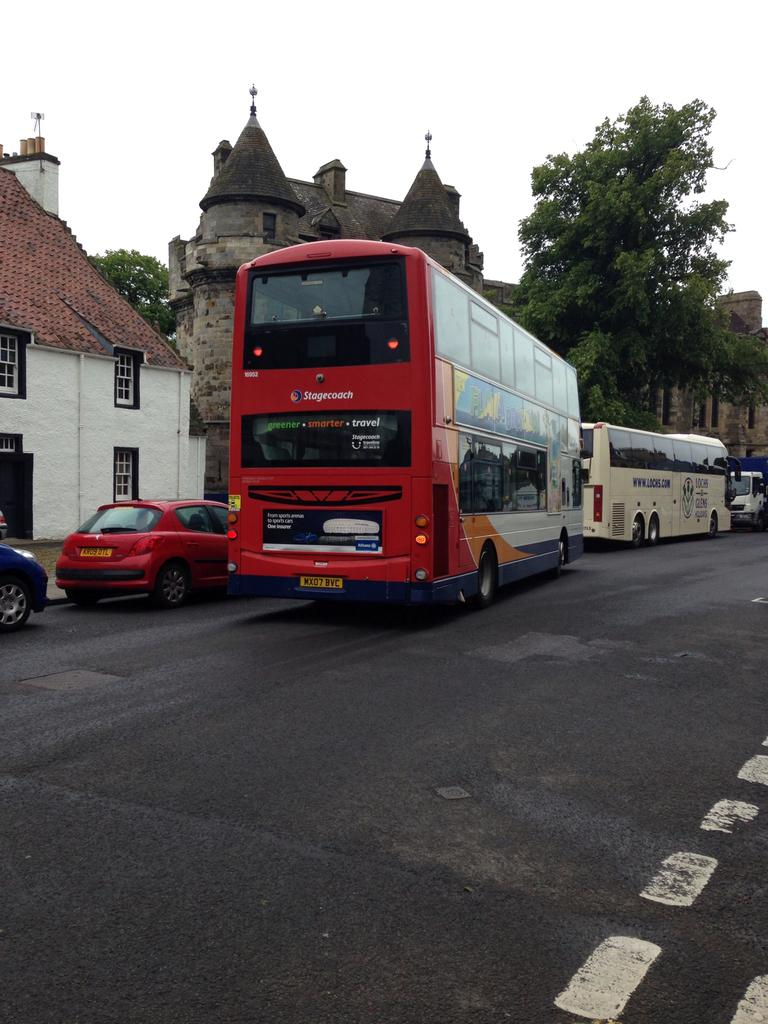Provide a one-sentence caption for the provided image. A red Stagecoach double decker bus on a street. 